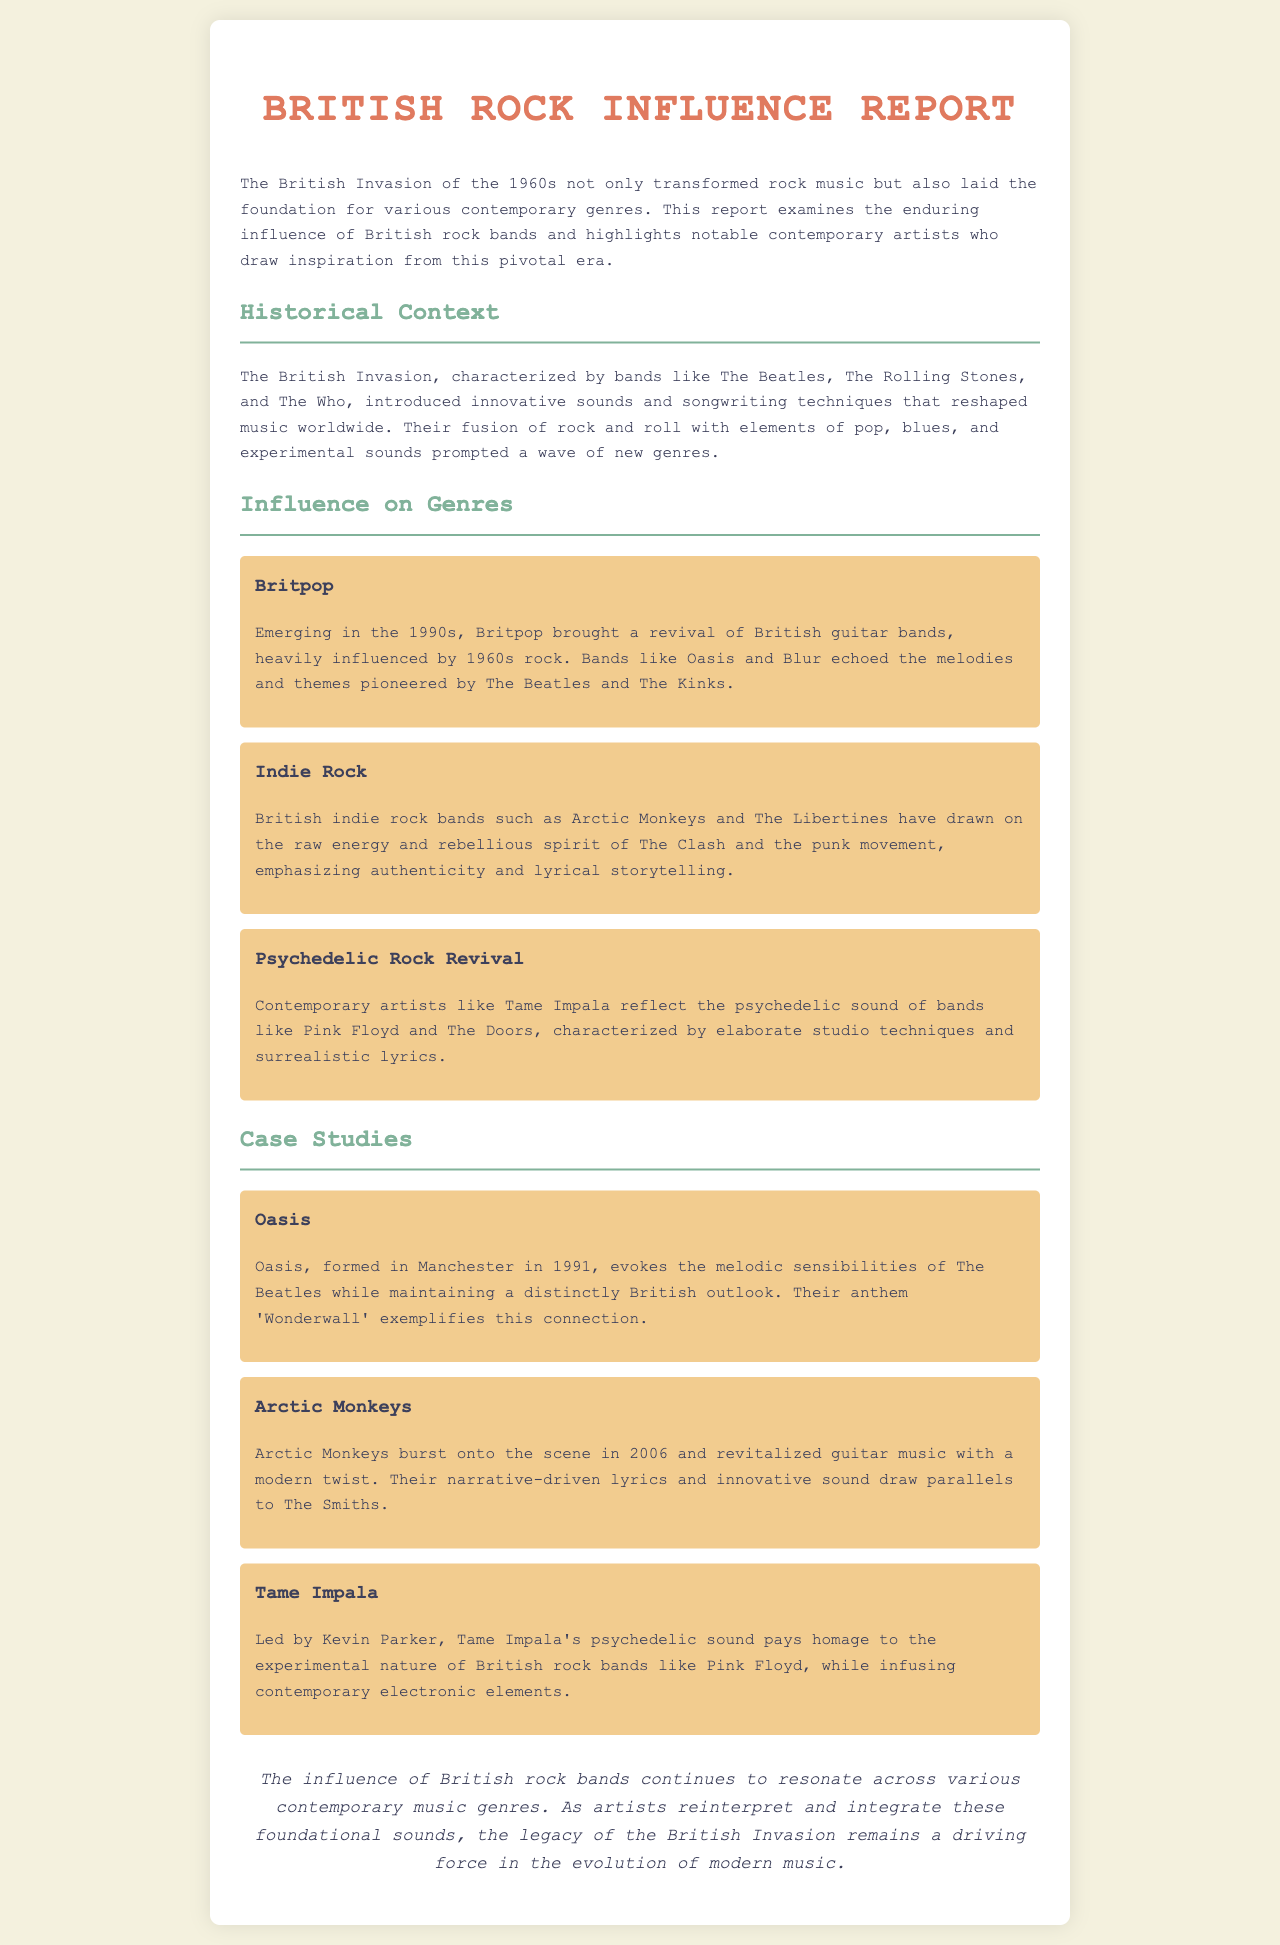What was the British Invasion? The British Invasion was characterized by bands that transformed rock music and laid the foundation for various contemporary genres.
Answer: A musical movement Which band is associated with Britpop? Britpop was influenced heavily by bands from the 1960s, particularly The Beatles and The Kinks, which defines its characteristics.
Answer: Oasis What genre did Arctic Monkeys help revitalize? Arctic Monkeys are notable for revitalizing a specific genre through their modern twist on traditional sounds.
Answer: Guitar music What year was Oasis formed? Oasis was formed in Manchester and made its debut in the early 90s, specifically in 1991.
Answer: 1991 Which contemporary artist is linked to the psychedelic rock revival? The psychedelic rock revival in contemporary music connects with bands that harken back to earlier psychedelic sounds.
Answer: Tame Impala What city is associated with Oasis? The formation of Oasis is noted to take place in a particular city that had its own music scene in the 90s.
Answer: Manchester Which British rock bands influenced indie rock? The indie rock surge was closely linked to iconic British bands, particularly The Clash and the punk movement.
Answer: The Clash What is the conclusion of the report? The report emphasizes the continued resonance of British rock bands across music genres, summarizing the findings.
Answer: The legacy of the British Invasion remains a driving force in the evolution of modern music 